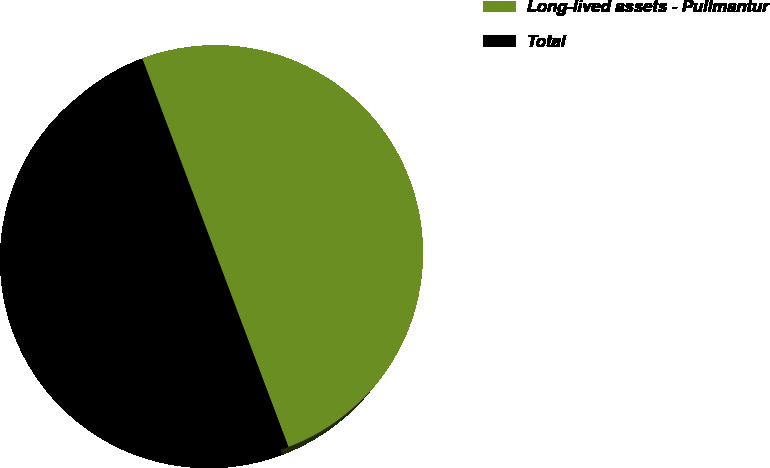Convert chart to OTSL. <chart><loc_0><loc_0><loc_500><loc_500><pie_chart><fcel>Long-lived assets - Pullmantur<fcel>Total<nl><fcel>50.0%<fcel>50.0%<nl></chart> 